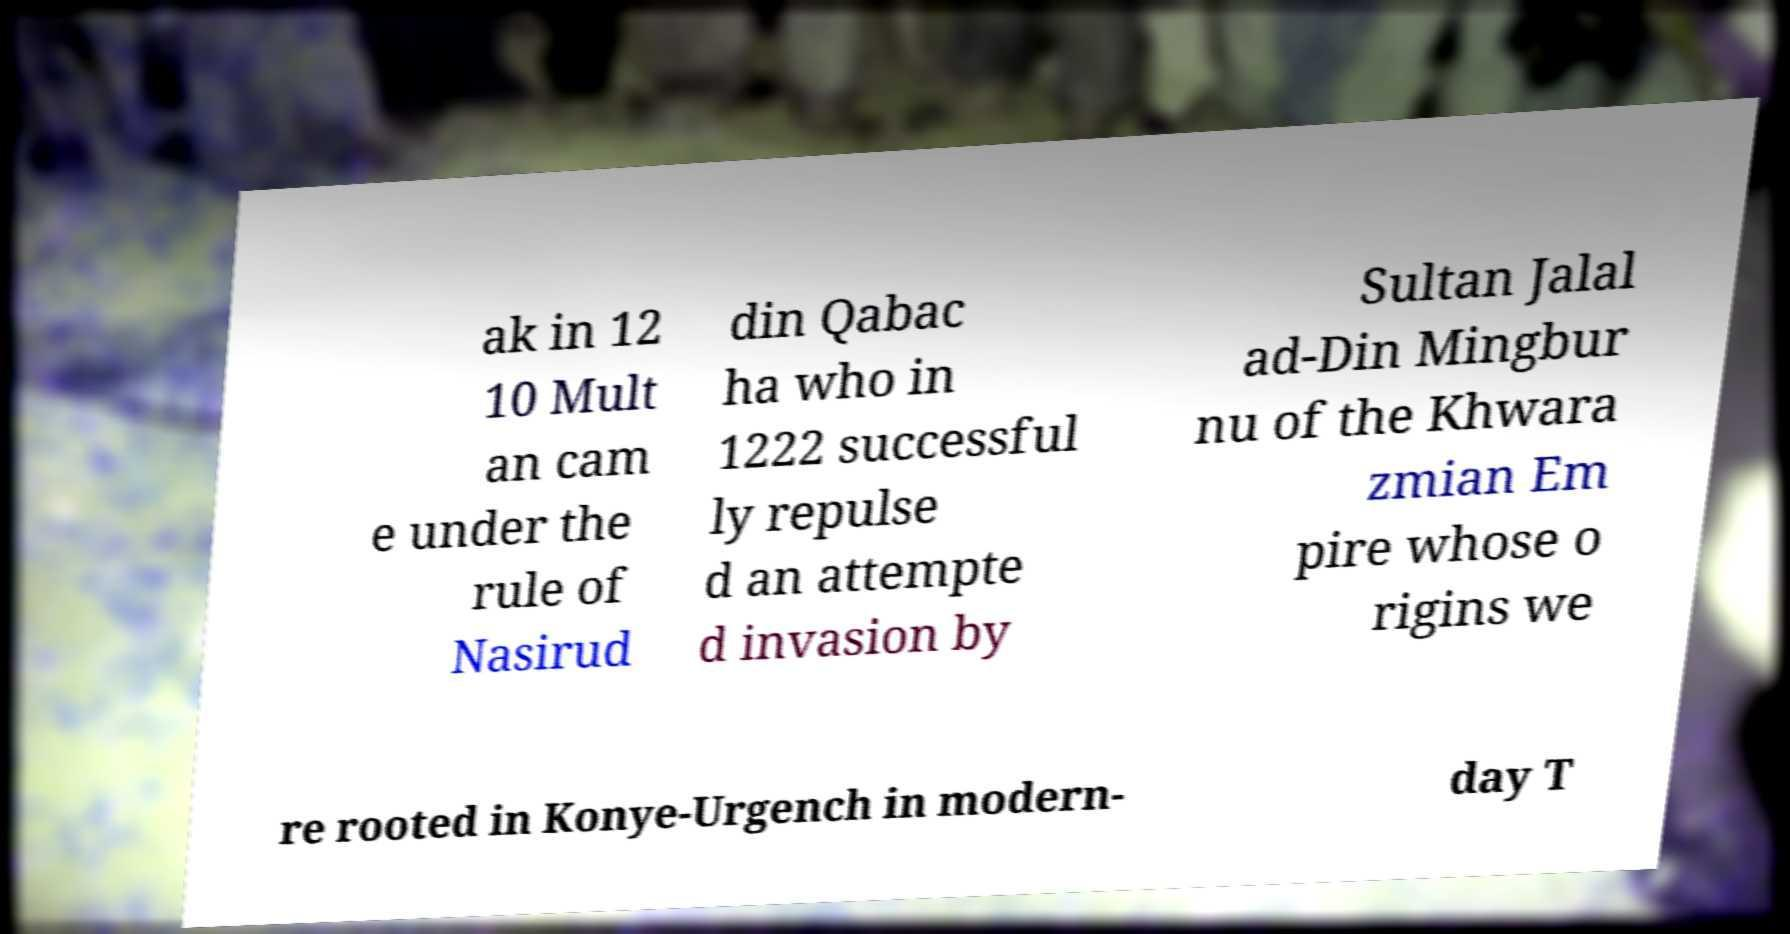Could you assist in decoding the text presented in this image and type it out clearly? ak in 12 10 Mult an cam e under the rule of Nasirud din Qabac ha who in 1222 successful ly repulse d an attempte d invasion by Sultan Jalal ad-Din Mingbur nu of the Khwara zmian Em pire whose o rigins we re rooted in Konye-Urgench in modern- day T 